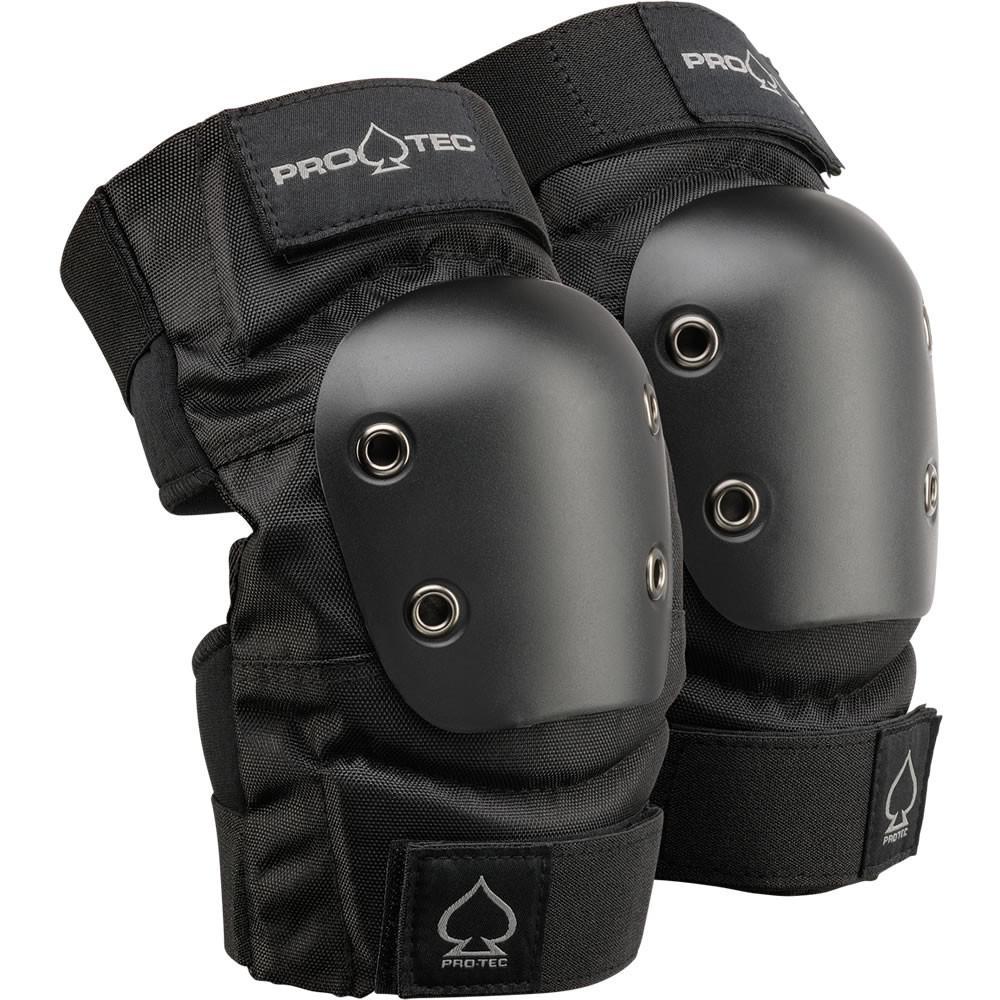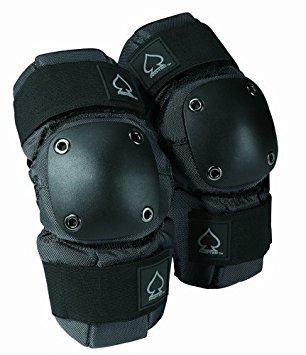The first image is the image on the left, the second image is the image on the right. For the images displayed, is the sentence "All the pads are facing right." factually correct? Answer yes or no. Yes. The first image is the image on the left, the second image is the image on the right. Examine the images to the left and right. Is the description "there are 4 knee pads in each image pair" accurate? Answer yes or no. Yes. 